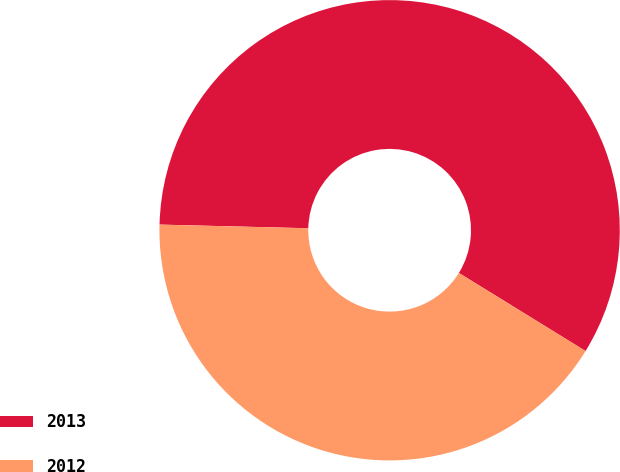<chart> <loc_0><loc_0><loc_500><loc_500><pie_chart><fcel>2013<fcel>2012<nl><fcel>58.4%<fcel>41.6%<nl></chart> 